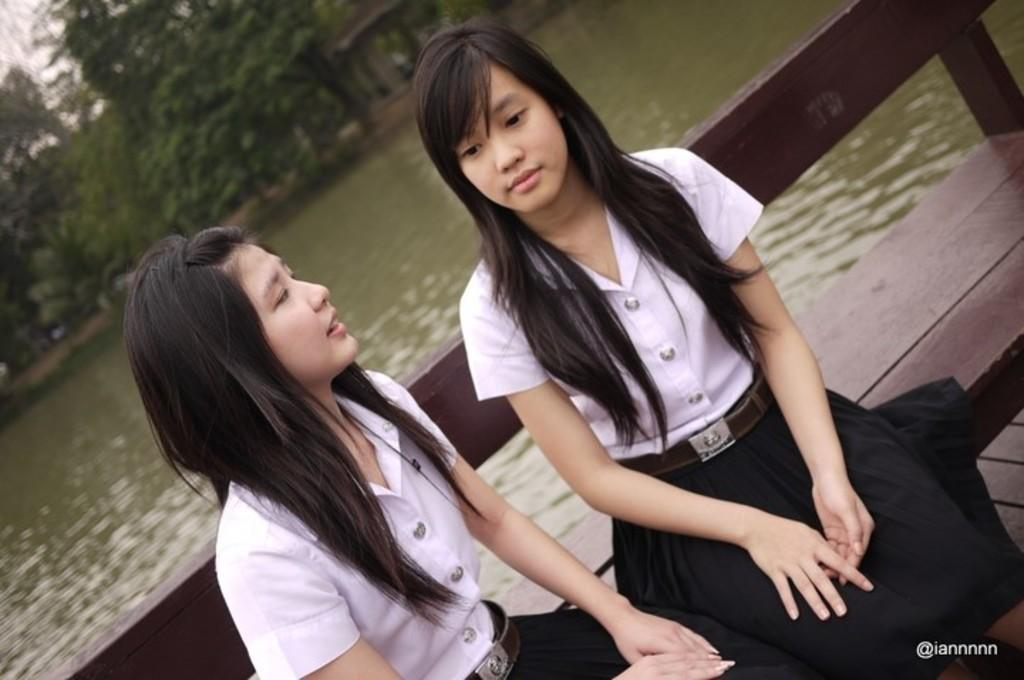How many women are sitting on the bench in the image? There are two women sitting on a bench in the image. What is visible behind the women? Water and trees are visible behind the women. What is visible in the sky in the image? The sky is visible in the image. Is there any indication of a watermark on the image? Yes, there is a watermark on the image. What type of brush is being used by the representative in the image? There is no representative or brush present in the image. Where is the camp located in the image? There is no camp present in the image. 